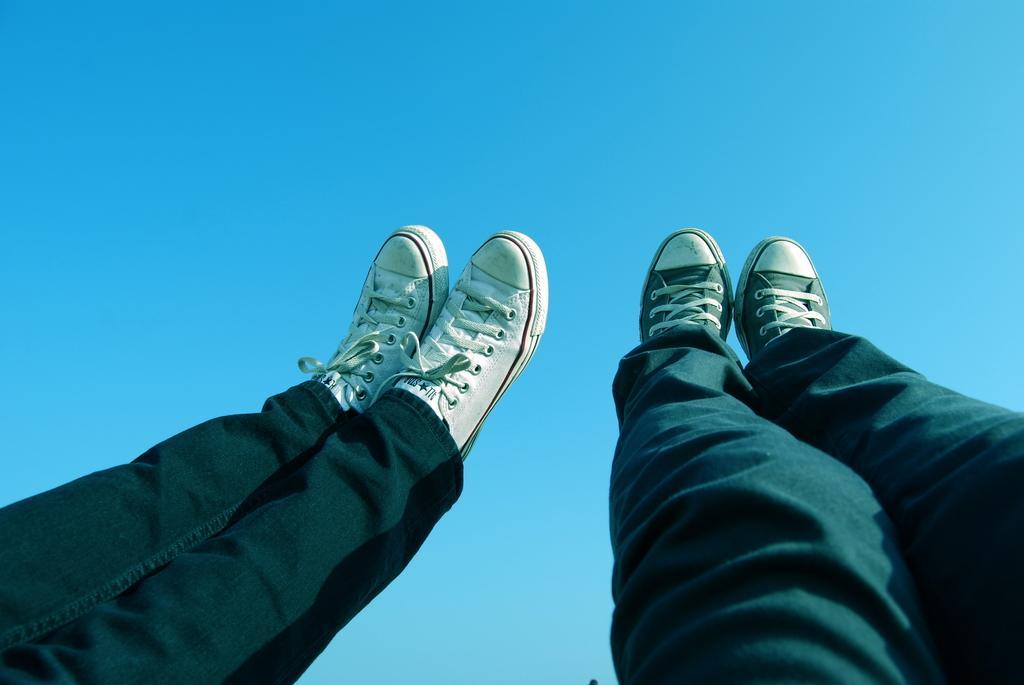In one or two sentences, can you explain what this image depicts? In this picture we can see legs of two persons, they wore shoes, we can see the sky in the background. 